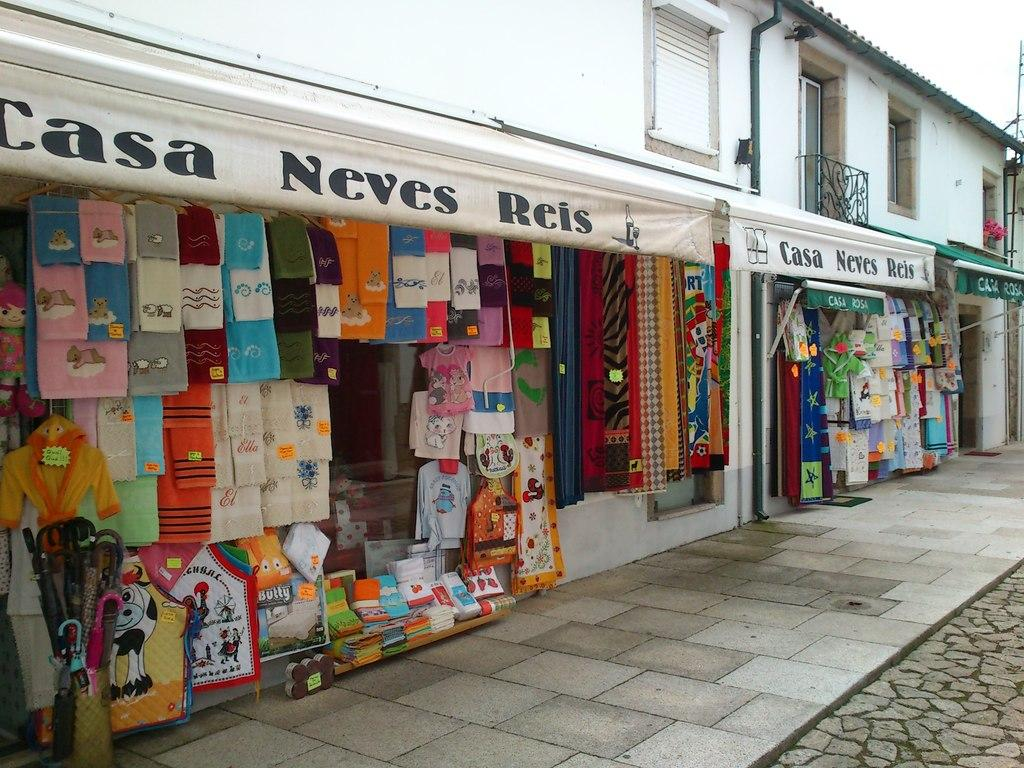<image>
Create a compact narrative representing the image presented. Casa Neves Reis has many towels for sale. 